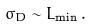<formula> <loc_0><loc_0><loc_500><loc_500>\sigma _ { D } \sim L _ { \min } \, .</formula> 